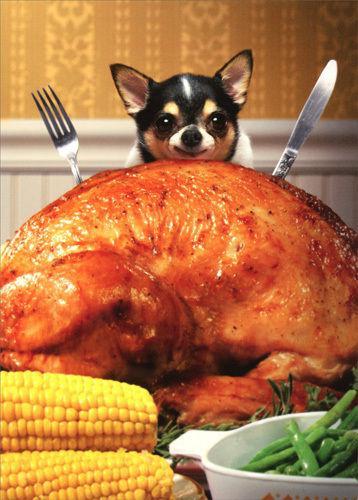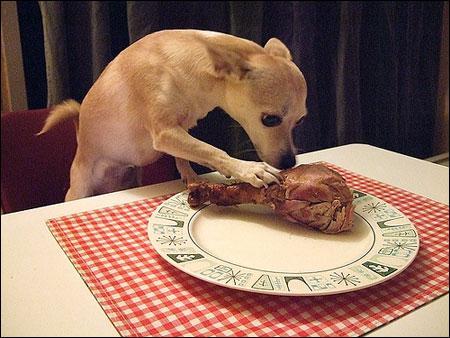The first image is the image on the left, the second image is the image on the right. Examine the images to the left and right. Is the description "There is a chihuahua that is wearing a costume in each image." accurate? Answer yes or no. No. The first image is the image on the left, the second image is the image on the right. For the images displayed, is the sentence "The dog in the image on the left is sitting before a plate of human food." factually correct? Answer yes or no. Yes. 